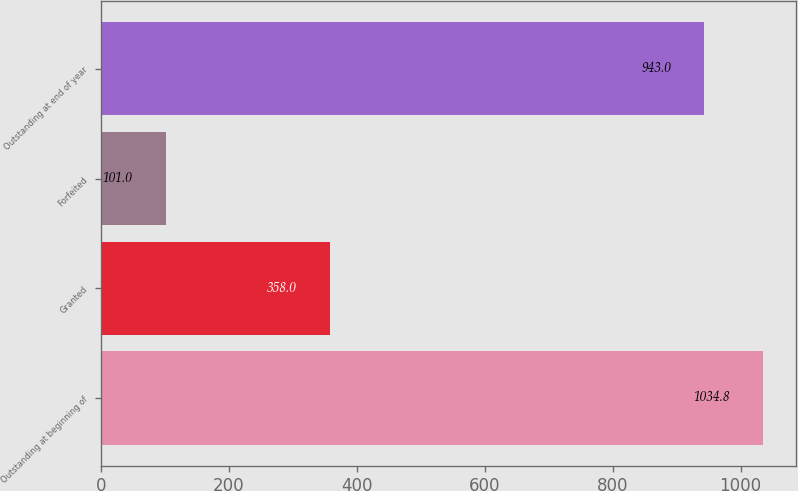Convert chart to OTSL. <chart><loc_0><loc_0><loc_500><loc_500><bar_chart><fcel>Outstanding at beginning of<fcel>Granted<fcel>Forfeited<fcel>Outstanding at end of year<nl><fcel>1034.8<fcel>358<fcel>101<fcel>943<nl></chart> 